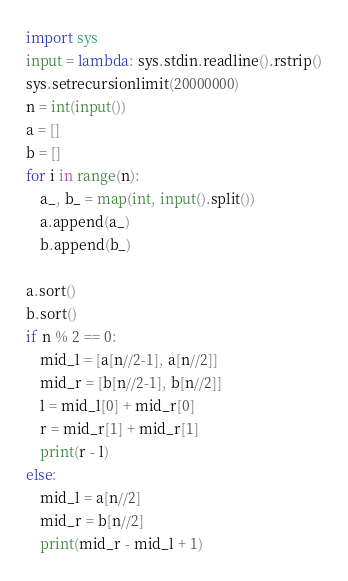<code> <loc_0><loc_0><loc_500><loc_500><_Python_>import sys
input = lambda: sys.stdin.readline().rstrip()
sys.setrecursionlimit(20000000)
n = int(input())
a = []
b = []
for i in range(n):
    a_, b_ = map(int, input().split())
    a.append(a_)
    b.append(b_)

a.sort()
b.sort()
if n % 2 == 0:
    mid_l = [a[n//2-1], a[n//2]]
    mid_r = [b[n//2-1], b[n//2]]
    l = mid_l[0] + mid_r[0]
    r = mid_r[1] + mid_r[1]
    print(r - l)
else:
    mid_l = a[n//2]
    mid_r = b[n//2]
    print(mid_r - mid_l + 1)</code> 